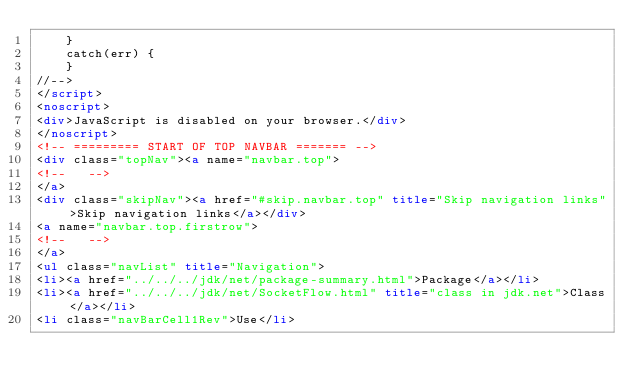<code> <loc_0><loc_0><loc_500><loc_500><_HTML_>    }
    catch(err) {
    }
//-->
</script>
<noscript>
<div>JavaScript is disabled on your browser.</div>
</noscript>
<!-- ========= START OF TOP NAVBAR ======= -->
<div class="topNav"><a name="navbar.top">
<!--   -->
</a>
<div class="skipNav"><a href="#skip.navbar.top" title="Skip navigation links">Skip navigation links</a></div>
<a name="navbar.top.firstrow">
<!--   -->
</a>
<ul class="navList" title="Navigation">
<li><a href="../../../jdk/net/package-summary.html">Package</a></li>
<li><a href="../../../jdk/net/SocketFlow.html" title="class in jdk.net">Class</a></li>
<li class="navBarCell1Rev">Use</li></code> 